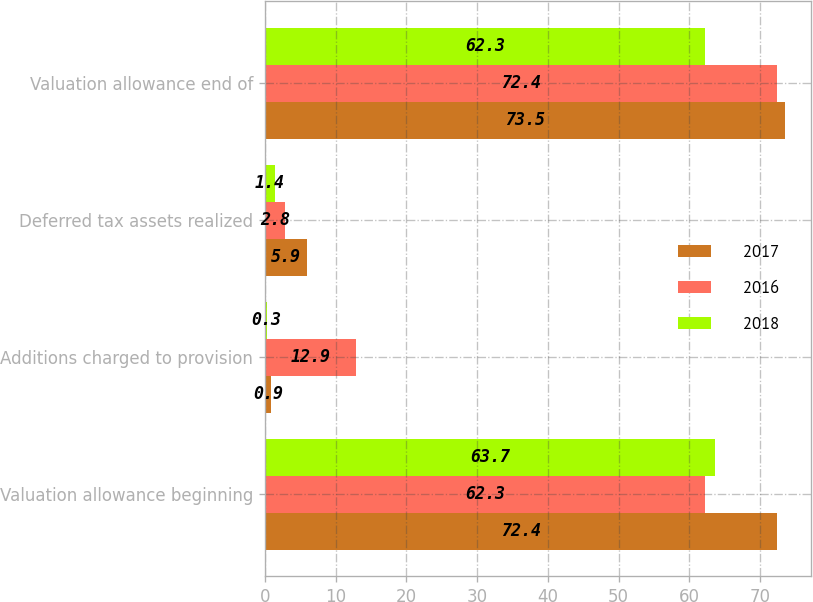<chart> <loc_0><loc_0><loc_500><loc_500><stacked_bar_chart><ecel><fcel>Valuation allowance beginning<fcel>Additions charged to provision<fcel>Deferred tax assets realized<fcel>Valuation allowance end of<nl><fcel>2017<fcel>72.4<fcel>0.9<fcel>5.9<fcel>73.5<nl><fcel>2016<fcel>62.3<fcel>12.9<fcel>2.8<fcel>72.4<nl><fcel>2018<fcel>63.7<fcel>0.3<fcel>1.4<fcel>62.3<nl></chart> 